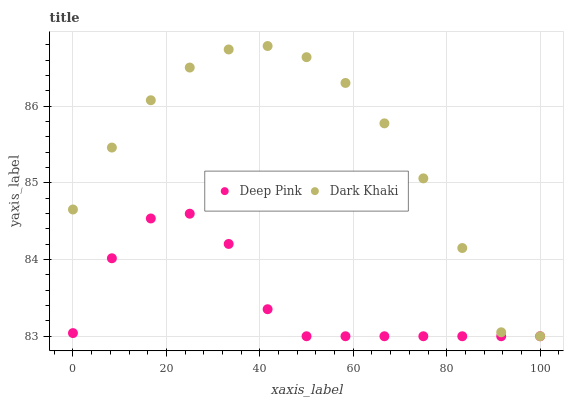Does Deep Pink have the minimum area under the curve?
Answer yes or no. Yes. Does Dark Khaki have the maximum area under the curve?
Answer yes or no. Yes. Does Deep Pink have the maximum area under the curve?
Answer yes or no. No. Is Deep Pink the smoothest?
Answer yes or no. Yes. Is Dark Khaki the roughest?
Answer yes or no. Yes. Is Deep Pink the roughest?
Answer yes or no. No. Does Dark Khaki have the lowest value?
Answer yes or no. Yes. Does Dark Khaki have the highest value?
Answer yes or no. Yes. Does Deep Pink have the highest value?
Answer yes or no. No. Does Dark Khaki intersect Deep Pink?
Answer yes or no. Yes. Is Dark Khaki less than Deep Pink?
Answer yes or no. No. Is Dark Khaki greater than Deep Pink?
Answer yes or no. No. 